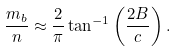<formula> <loc_0><loc_0><loc_500><loc_500>\frac { m _ { b } } { n } \approx \frac { 2 } { \pi } \tan ^ { - 1 } \left ( \frac { 2 B } { c } \right ) .</formula> 